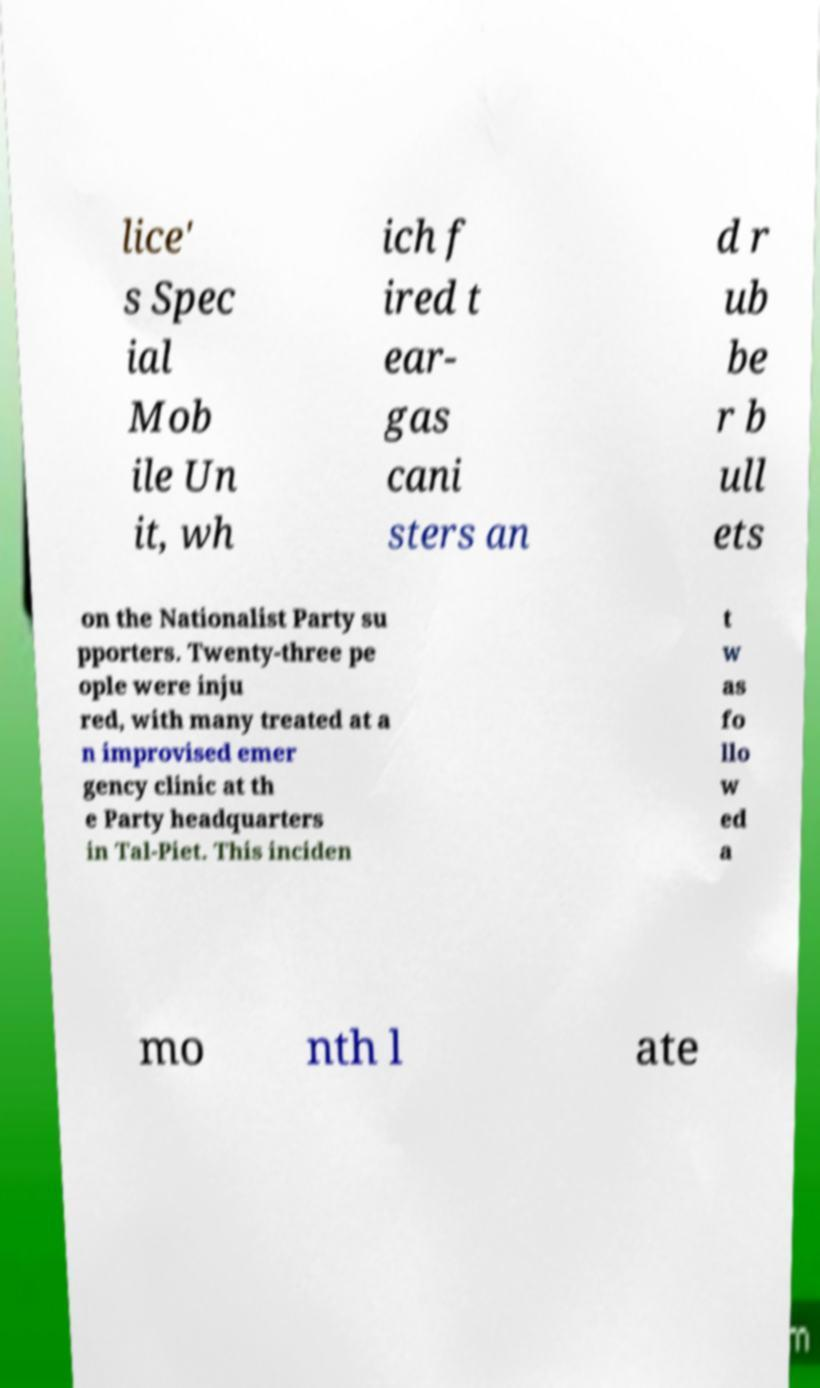There's text embedded in this image that I need extracted. Can you transcribe it verbatim? lice' s Spec ial Mob ile Un it, wh ich f ired t ear- gas cani sters an d r ub be r b ull ets on the Nationalist Party su pporters. Twenty-three pe ople were inju red, with many treated at a n improvised emer gency clinic at th e Party headquarters in Tal-Piet. This inciden t w as fo llo w ed a mo nth l ate 